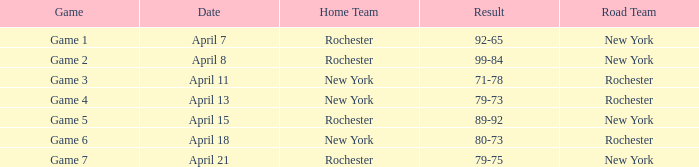Which team, playing on the road, competed against the home team of rochester and had a game outcome of 89-92? New York. 